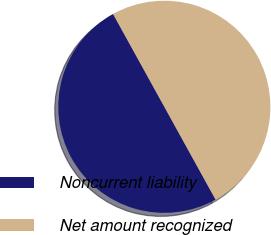Convert chart to OTSL. <chart><loc_0><loc_0><loc_500><loc_500><pie_chart><fcel>Noncurrent liability<fcel>Net amount recognized<nl><fcel>50.0%<fcel>50.0%<nl></chart> 